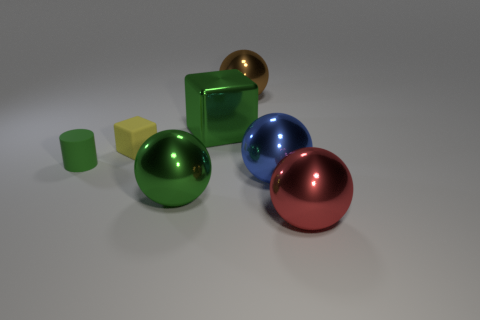Add 1 small yellow metallic cylinders. How many objects exist? 8 Subtract all big red spheres. How many spheres are left? 3 Subtract all brown balls. How many balls are left? 3 Subtract 4 spheres. How many spheres are left? 0 Subtract all large metallic things. Subtract all blue shiny spheres. How many objects are left? 1 Add 1 tiny green things. How many tiny green things are left? 2 Add 4 green cylinders. How many green cylinders exist? 5 Subtract 0 gray spheres. How many objects are left? 7 Subtract all spheres. How many objects are left? 3 Subtract all gray balls. Subtract all green blocks. How many balls are left? 4 